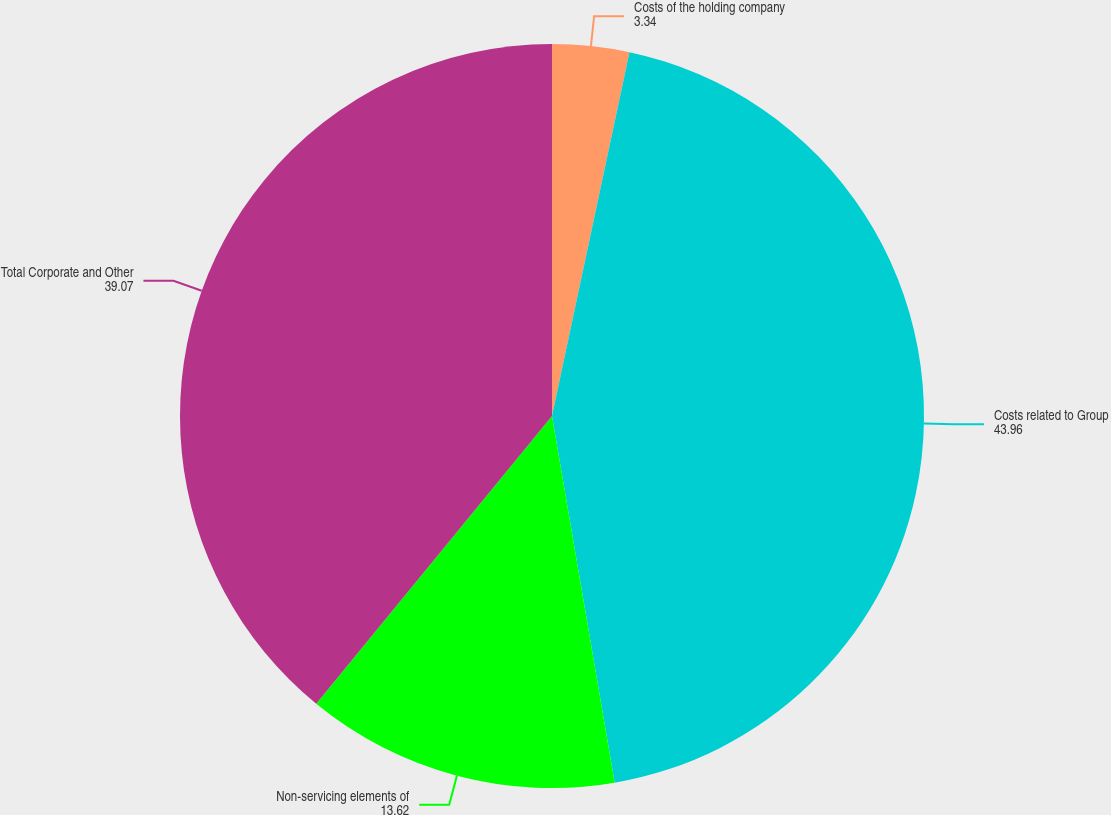<chart> <loc_0><loc_0><loc_500><loc_500><pie_chart><fcel>Costs of the holding company<fcel>Costs related to Group<fcel>Non-servicing elements of<fcel>Total Corporate and Other<nl><fcel>3.34%<fcel>43.96%<fcel>13.62%<fcel>39.07%<nl></chart> 